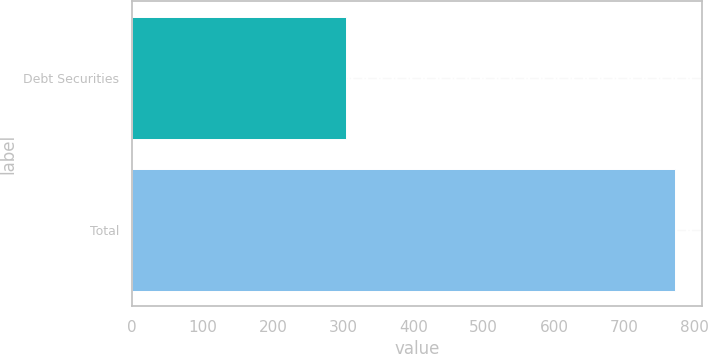<chart> <loc_0><loc_0><loc_500><loc_500><bar_chart><fcel>Debt Securities<fcel>Total<nl><fcel>303.9<fcel>771.3<nl></chart> 